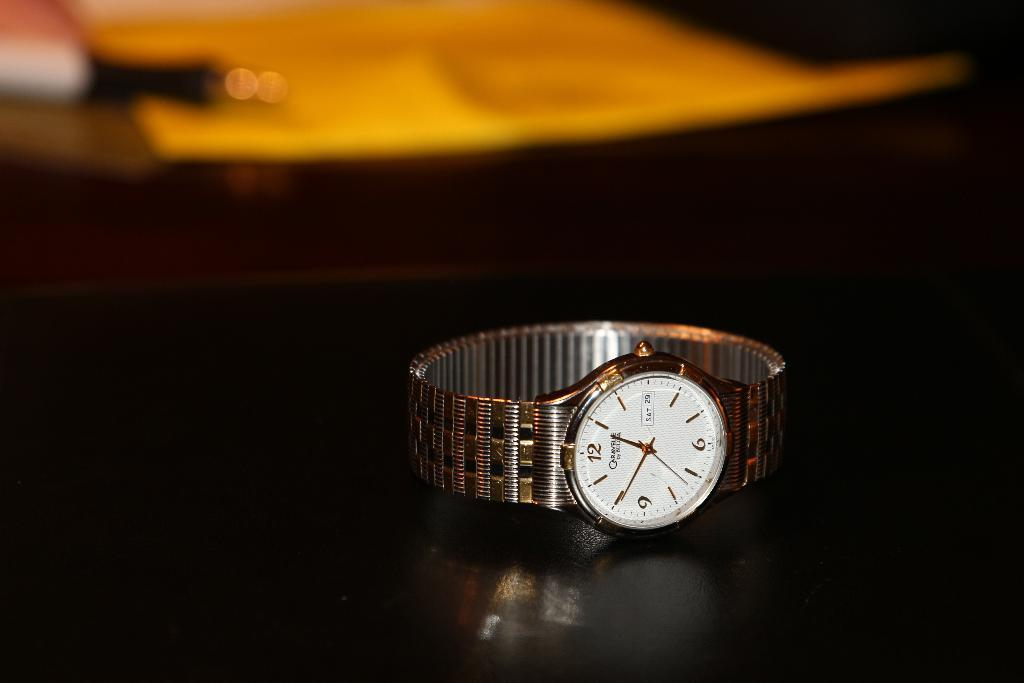Provide a one-sentence caption for the provided image. SIlver and white watch with the hands on the number 1 and 10. 